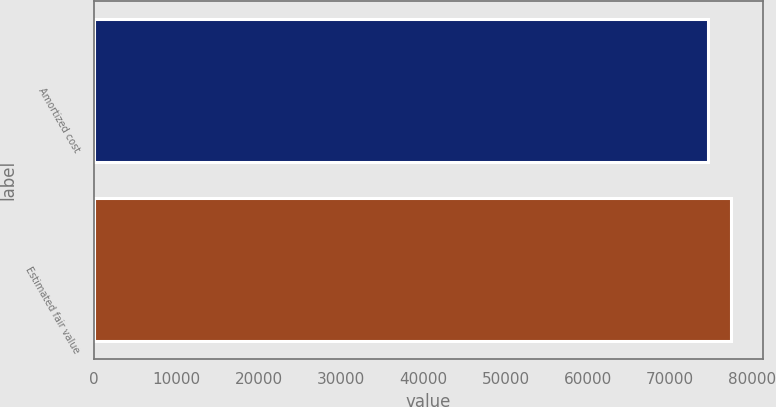<chart> <loc_0><loc_0><loc_500><loc_500><bar_chart><fcel>Amortized cost<fcel>Estimated fair value<nl><fcel>74554<fcel>77398<nl></chart> 